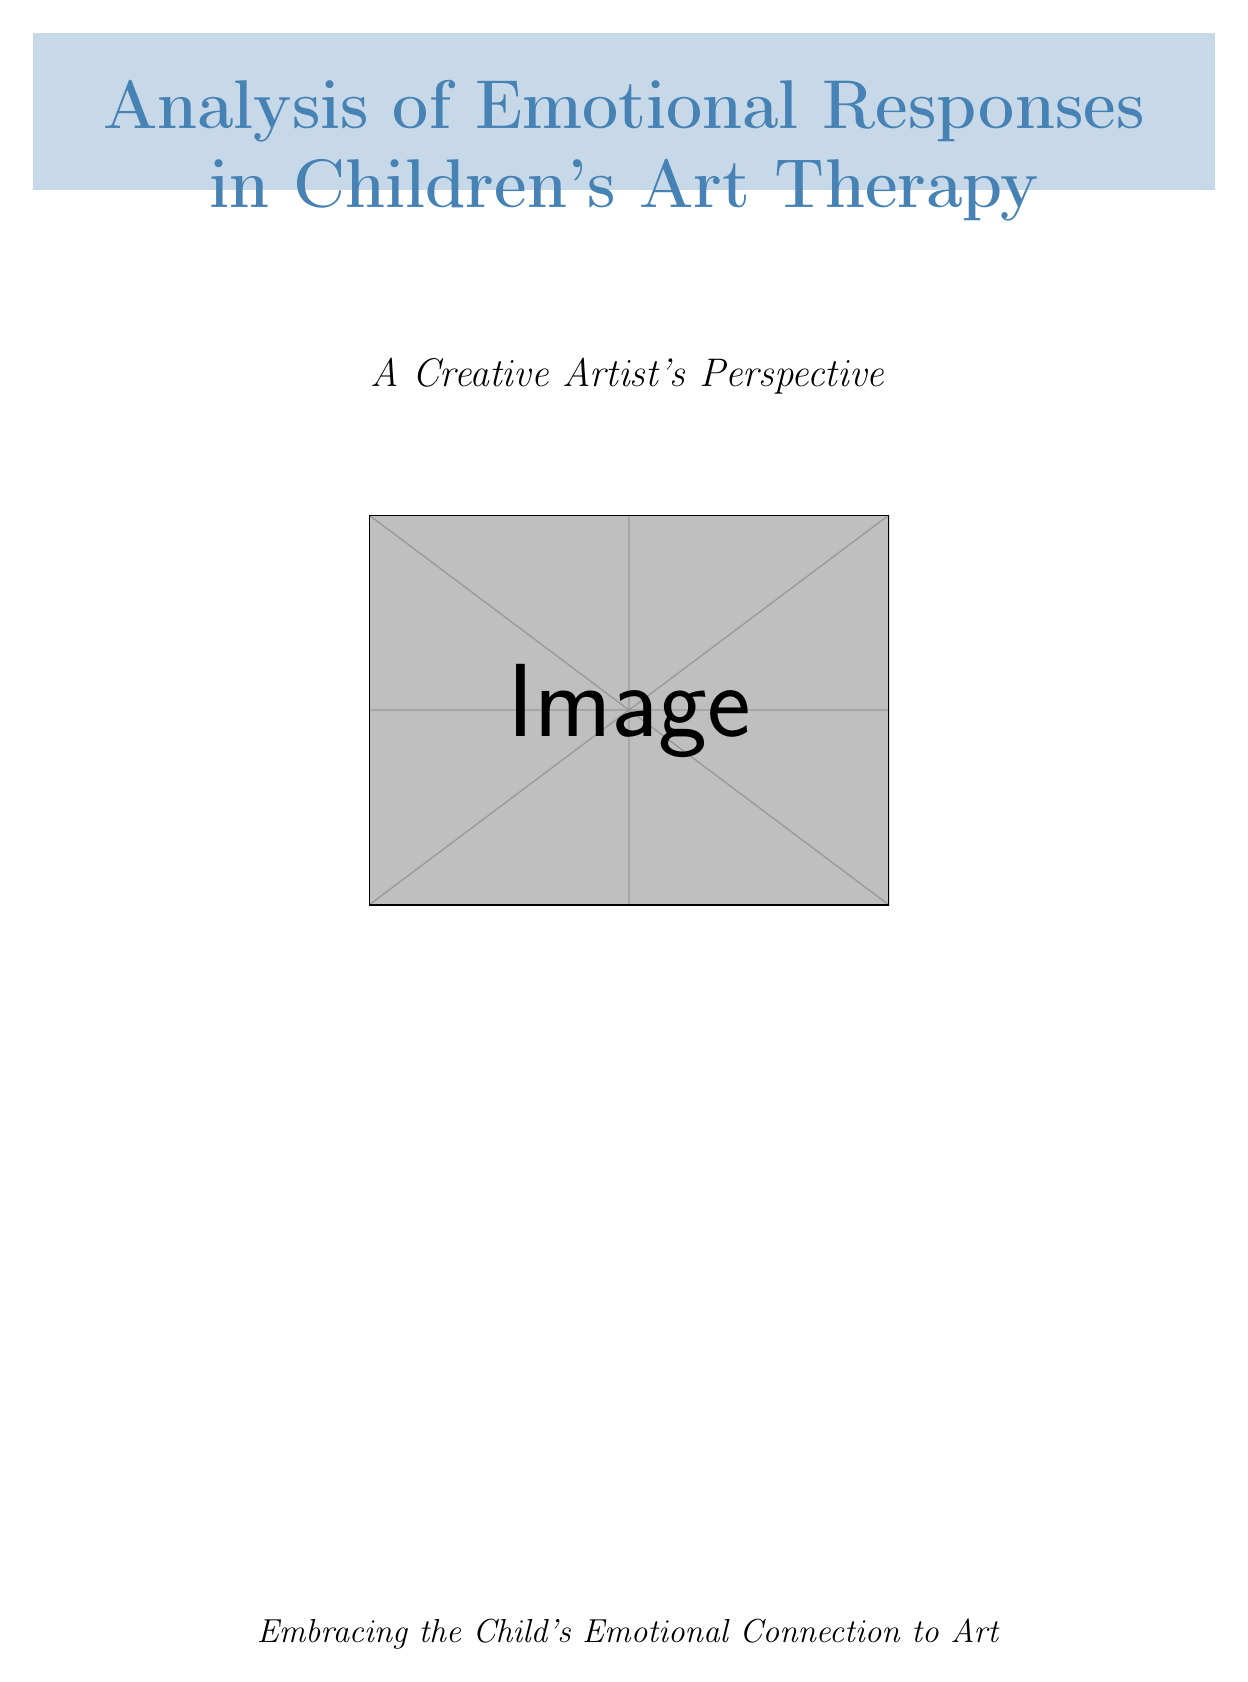what is the age of Emma? Emma is the patient in the case study titled "The Rainbow Bridge: Overcoming Grief," and her age is stated as 8 years old.
Answer: 8 years old what emotion did Liam initially experience in his art therapy session? The document states that Liam experienced initial fear in his emotional response during the art activity.
Answer: fear what is the main theme of Sophia's artwork? Sophia's artwork, a family collage, revolves around her experience of navigating divorce, as indicated in the analysis section.
Answer: navigating divorce how did Emma express her emotions through her artwork? The document describes Emma's emotional response as a cathartic expression of sadness and hope as she worked on the rainbow bridge.
Answer: sadness and hope what therapeutic technique was used with Liam? The technique described in the document that was applied to Liam is "Sequential Art," which involved creating a series of artworks.
Answer: Sequential Art what does the use of bright colors in children's artwork generally signify? The document explains that bright colors may indicate happiness or excitement in children's art, which is an example provided for Emma's artwork.
Answer: happiness or excitement how did Sophia symbolize her family dynamic in her collage? The analysis section indicates that Sophia used a bridge in her family collage to symbolize her desire for connection between her separated parents.
Answer: a bridge what was a common emotional response category identified in the analysis? One of the categories discussed in the emotional response patterns is "Color use," demonstrating how children utilize colors to represent emotions.
Answer: Color use 